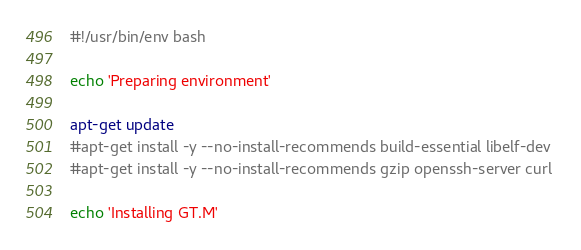Convert code to text. <code><loc_0><loc_0><loc_500><loc_500><_Bash_>#!/usr/bin/env bash

echo 'Preparing environment'

apt-get update
#apt-get install -y --no-install-recommends build-essential libelf-dev 
#apt-get install -y --no-install-recommends gzip openssh-server curl

echo 'Installing GT.M'</code> 